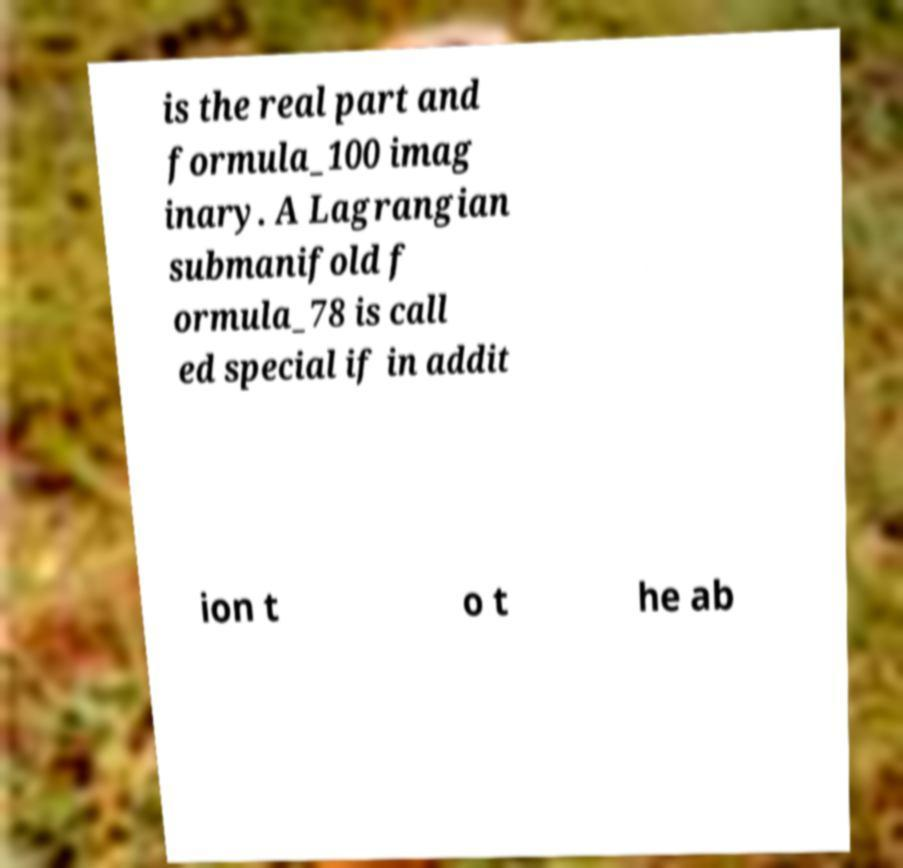Can you read and provide the text displayed in the image?This photo seems to have some interesting text. Can you extract and type it out for me? is the real part and formula_100 imag inary. A Lagrangian submanifold f ormula_78 is call ed special if in addit ion t o t he ab 